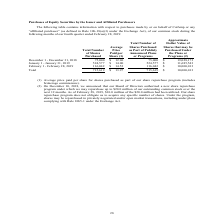Looking at Calamp's financial data, please calculate: How many shares were purchased in 2019? Based on the calculation: (524,577+116,042), the result is 640619. This is based on the information: "4,577 $ 11,685,543 February 1 - February 28, 2019 116,042 $ 14.53 116,042 $ 10,000,013 Total 715,619 $ 13.97 715,619 $ 10,000,013 75,000 $ 19,028,173 January 1 - January 31, 2019 524,577 $ 14.00 524,5..." The key data points involved are: 116,042, 524,577. Also, How many shares did the company purchase in December 2018? According to the financial document, 75,000. The relevant text states: "ns or Programs (2) December 1 - December 31, 2018 75,000 $ 12.96 75,000 $ 19,028,173 January 1 - January 31, 2019 524,577 $ 14.00 524,577 $ 11,685,543 Febru..." Also, What was the approximate dollar value of shares that may be purchased under the plans or program in December 2018? According to the financial document, $19,028,173. The relevant text states: "ber 1 - December 31, 2018 75,000 $ 12.96 75,000 $ 19,028,173 January 1 - January 31, 2019 524,577 $ 14.00 524,577 $ 11,685,543 February 1 - February 28, 2019 11..." Also, can you calculate: What is the percentage increase in total number of shares purchased between December 2018 and January 2019? To answer this question, I need to perform calculations using the financial data. The calculation is: [(524,577-75,000)/75,000], which equals 599.44 (percentage). This is based on the information: "75,000 $ 19,028,173 January 1 - January 31, 2019 524,577 $ 14.00 524,577 $ 11,685,543 February 1 - February 28, 2019 116,042 $ 14.53 116,042 $ 10,000,013 To ns or Programs (2) December 1 - December 31..." The key data points involved are: 524,577, 75,000. Also, can you calculate: What is the percentage change in Total number of shares purchased between January 2019 and February 2019? To answer this question, I need to perform calculations using the financial data. The calculation is: (116,042-524,577)/524,577, which equals -77.88 (percentage). This is based on the information: "4,577 $ 11,685,543 February 1 - February 28, 2019 116,042 $ 14.53 116,042 $ 10,000,013 Total 715,619 $ 13.97 715,619 $ 10,000,013 75,000 $ 19,028,173 January 1 - January 31, 2019 524,577 $ 14.00 524,5..." The key data points involved are: 116,042, 524,577. Also, How many shares did the company purchase in February 2019? According to the financial document, 116,042. The relevant text states: "4,577 $ 11,685,543 February 1 - February 28, 2019 116,042 $ 14.53 116,042 $ 10,000,013 Total 715,619 $ 13.97 715,619 $ 10,000,013..." 